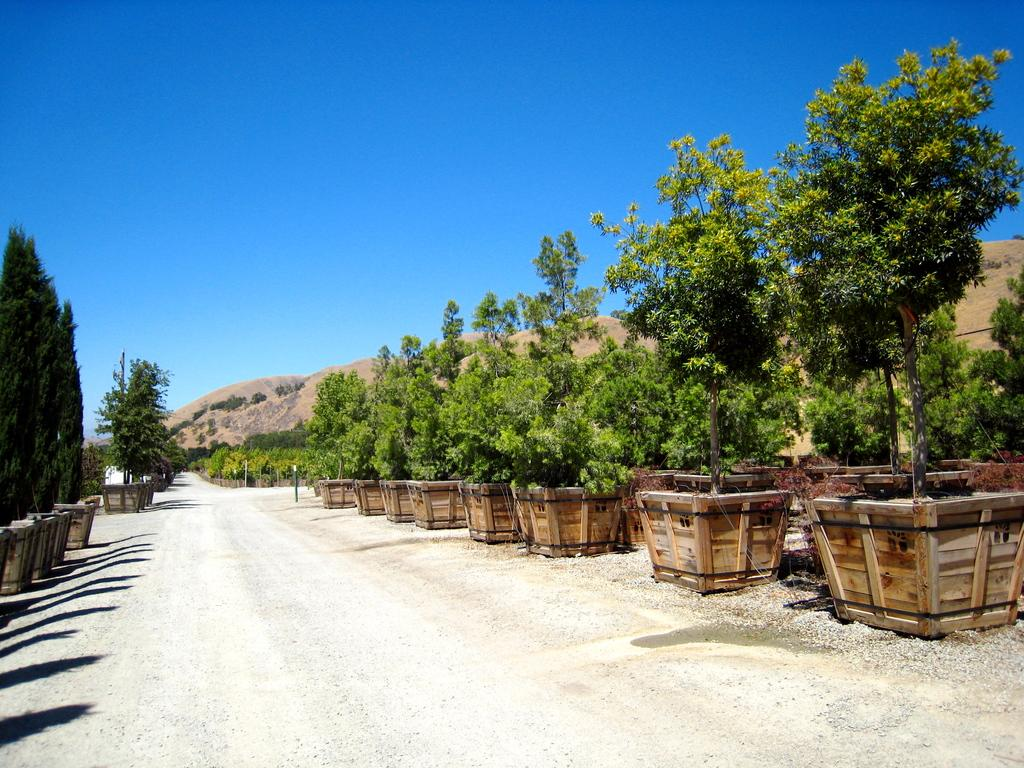What is the main feature of the image? There is a road in the image. Are there any other objects or elements present in the image? Yes, there are potted plants in the image. Where is the faucet located in the image? There is no faucet present in the image. What type of knot can be seen tied around the potted plants in the image? There are no knots present around the potted plants in the image. 